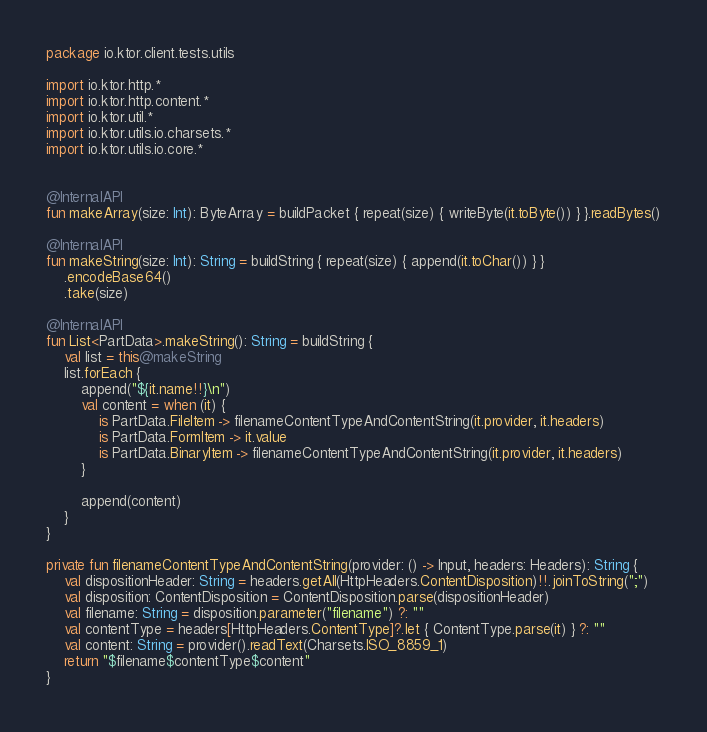<code> <loc_0><loc_0><loc_500><loc_500><_Kotlin_>
package io.ktor.client.tests.utils

import io.ktor.http.*
import io.ktor.http.content.*
import io.ktor.util.*
import io.ktor.utils.io.charsets.*
import io.ktor.utils.io.core.*


@InternalAPI
fun makeArray(size: Int): ByteArray = buildPacket { repeat(size) { writeByte(it.toByte()) } }.readBytes()

@InternalAPI
fun makeString(size: Int): String = buildString { repeat(size) { append(it.toChar()) } }
    .encodeBase64()
    .take(size)

@InternalAPI
fun List<PartData>.makeString(): String = buildString {
    val list = this@makeString
    list.forEach {
        append("${it.name!!}\n")
        val content = when (it) {
            is PartData.FileItem -> filenameContentTypeAndContentString(it.provider, it.headers)
            is PartData.FormItem -> it.value
            is PartData.BinaryItem -> filenameContentTypeAndContentString(it.provider, it.headers)
        }

        append(content)
    }
}

private fun filenameContentTypeAndContentString(provider: () -> Input, headers: Headers): String {
    val dispositionHeader: String = headers.getAll(HttpHeaders.ContentDisposition)!!.joinToString(";")
    val disposition: ContentDisposition = ContentDisposition.parse(dispositionHeader)
    val filename: String = disposition.parameter("filename") ?: ""
    val contentType = headers[HttpHeaders.ContentType]?.let { ContentType.parse(it) } ?: ""
    val content: String = provider().readText(Charsets.ISO_8859_1)
    return "$filename$contentType$content"
}
</code> 